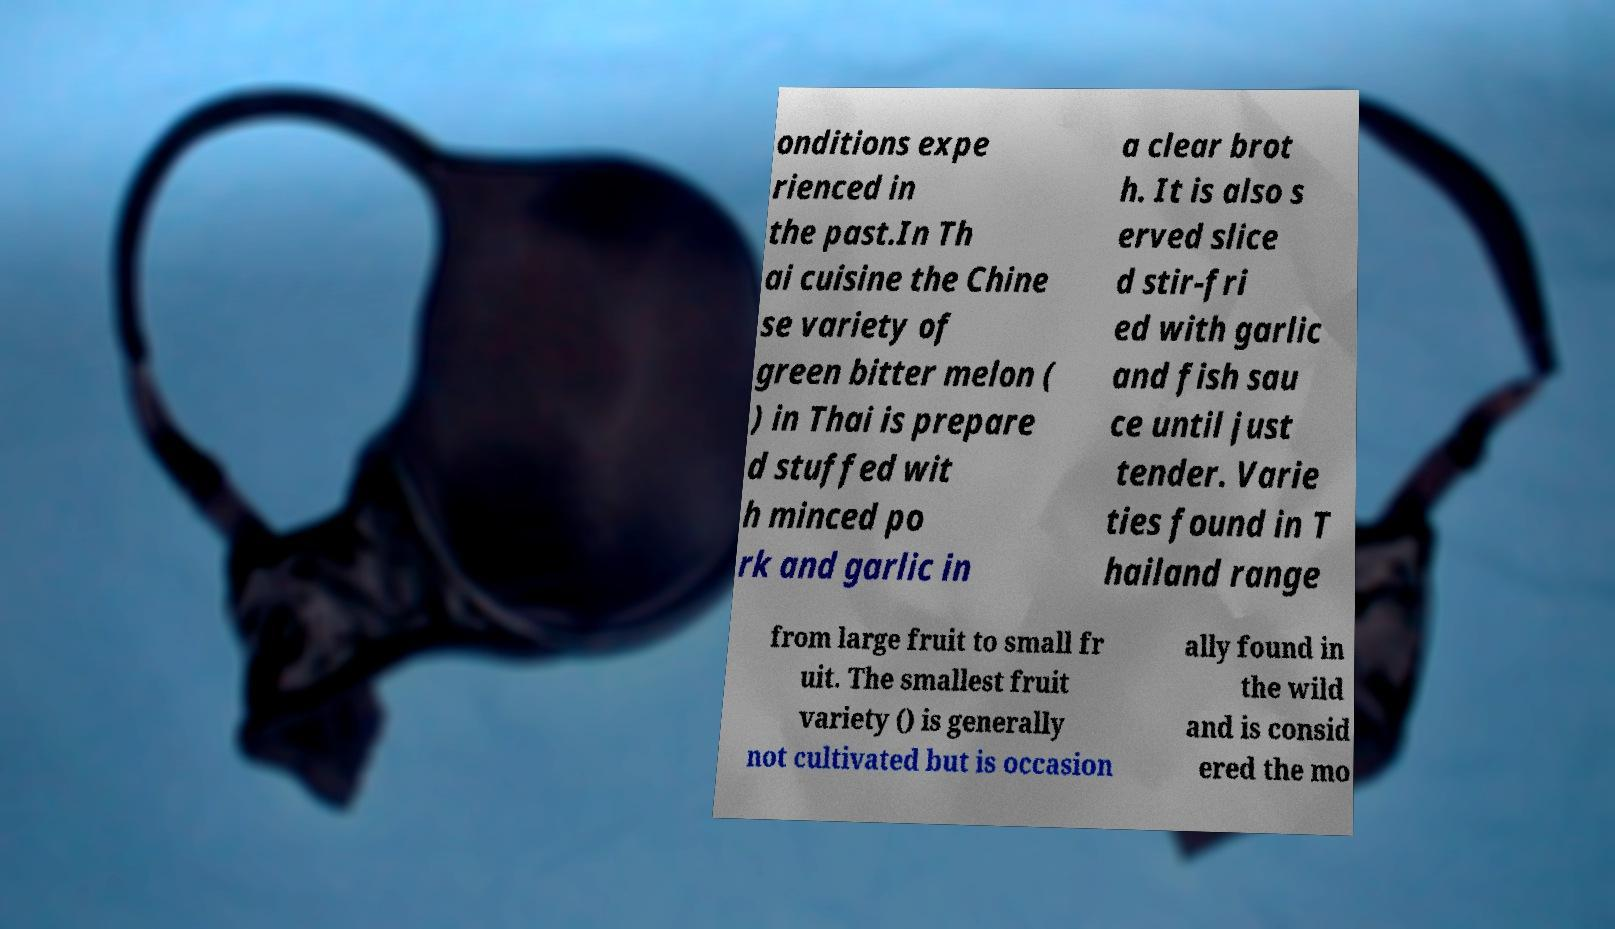Can you accurately transcribe the text from the provided image for me? onditions expe rienced in the past.In Th ai cuisine the Chine se variety of green bitter melon ( ) in Thai is prepare d stuffed wit h minced po rk and garlic in a clear brot h. It is also s erved slice d stir-fri ed with garlic and fish sau ce until just tender. Varie ties found in T hailand range from large fruit to small fr uit. The smallest fruit variety () is generally not cultivated but is occasion ally found in the wild and is consid ered the mo 